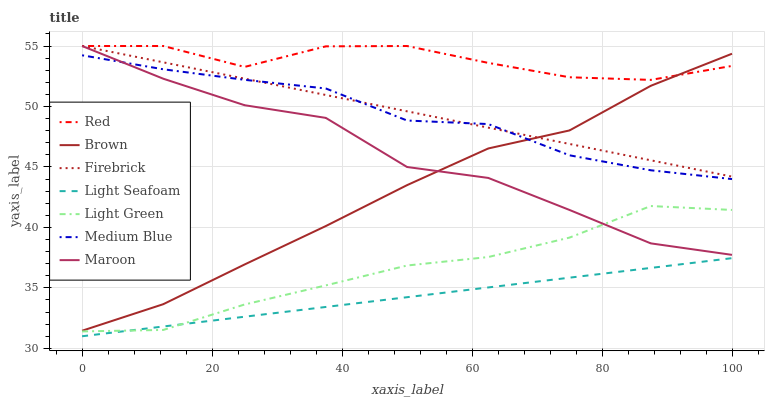Does Light Seafoam have the minimum area under the curve?
Answer yes or no. Yes. Does Red have the maximum area under the curve?
Answer yes or no. Yes. Does Firebrick have the minimum area under the curve?
Answer yes or no. No. Does Firebrick have the maximum area under the curve?
Answer yes or no. No. Is Firebrick the smoothest?
Answer yes or no. Yes. Is Maroon the roughest?
Answer yes or no. Yes. Is Medium Blue the smoothest?
Answer yes or no. No. Is Medium Blue the roughest?
Answer yes or no. No. Does Light Seafoam have the lowest value?
Answer yes or no. Yes. Does Firebrick have the lowest value?
Answer yes or no. No. Does Red have the highest value?
Answer yes or no. Yes. Does Medium Blue have the highest value?
Answer yes or no. No. Is Light Seafoam less than Maroon?
Answer yes or no. Yes. Is Red greater than Light Green?
Answer yes or no. Yes. Does Medium Blue intersect Maroon?
Answer yes or no. Yes. Is Medium Blue less than Maroon?
Answer yes or no. No. Is Medium Blue greater than Maroon?
Answer yes or no. No. Does Light Seafoam intersect Maroon?
Answer yes or no. No. 